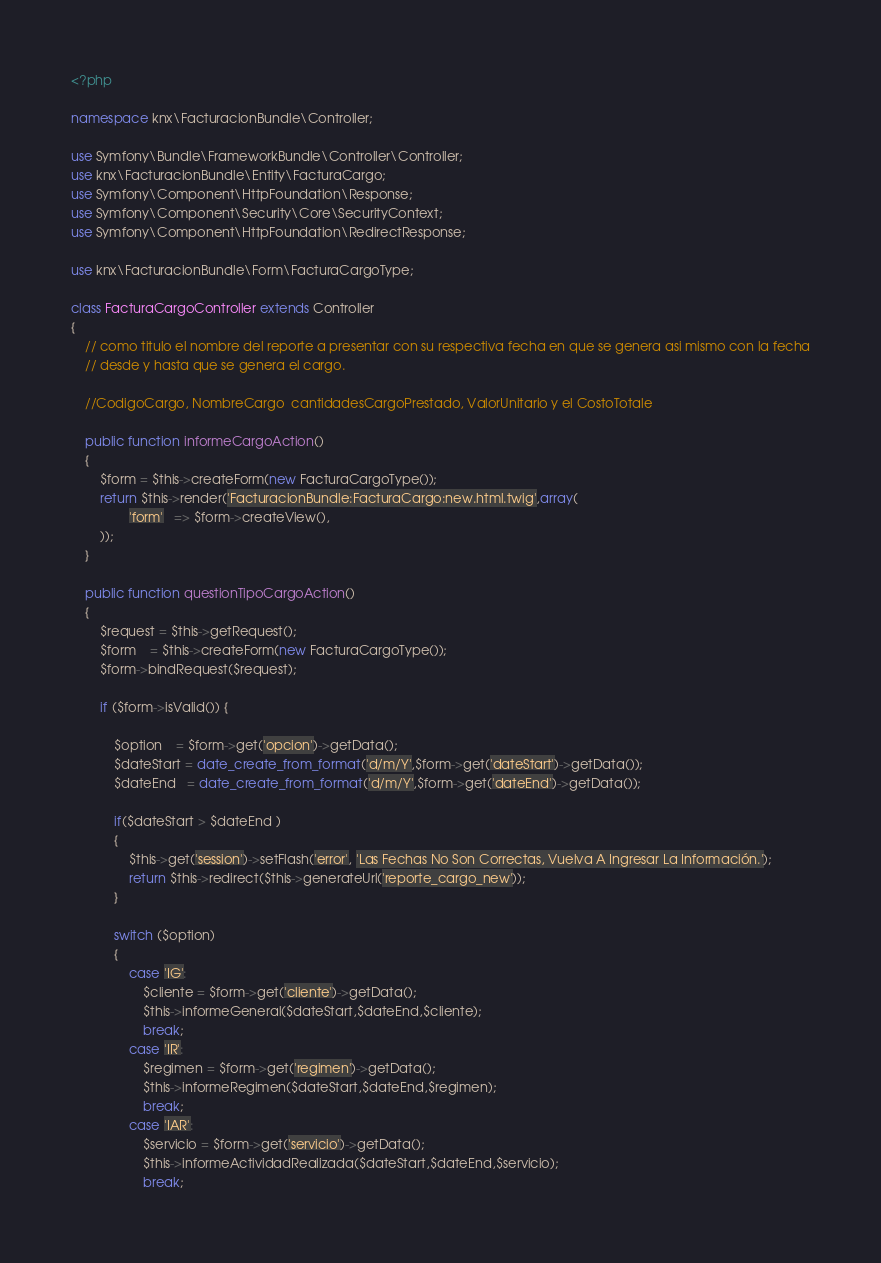Convert code to text. <code><loc_0><loc_0><loc_500><loc_500><_PHP_><?php

namespace knx\FacturacionBundle\Controller;

use Symfony\Bundle\FrameworkBundle\Controller\Controller;
use knx\FacturacionBundle\Entity\FacturaCargo;
use Symfony\Component\HttpFoundation\Response;
use Symfony\Component\Security\Core\SecurityContext;
use Symfony\Component\HttpFoundation\RedirectResponse;

use knx\FacturacionBundle\Form\FacturaCargoType;

class FacturaCargoController extends Controller
{
	// como titulo el nombre del reporte a presentar con su respectiva fecha en que se genera asi mismo con la fecha
	// desde y hasta que se genera el cargo.

	//CodigoCargo, NombreCargo  cantidadesCargoPrestado, ValorUnitario y el CostoTotale

	public function informeCargoAction()
	{
		$form = $this->createForm(new FacturaCargoType());
		return $this->render('FacturacionBundle:FacturaCargo:new.html.twig',array(
    			'form'   => $form->createView(),
    	));
	}

	public function questionTipoCargoAction()
	{
		$request = $this->getRequest();
		$form    = $this->createForm(new FacturaCargoType());
		$form->bindRequest($request);

		if ($form->isValid()) {

			$option    = $form->get('opcion')->getData();
			$dateStart = date_create_from_format('d/m/Y',$form->get('dateStart')->getData());
			$dateEnd   = date_create_from_format('d/m/Y',$form->get('dateEnd')->getData());

			if($dateStart > $dateEnd )
			{
				$this->get('session')->setFlash('error', 'Las Fechas No Son Correctas, Vuelva A Ingresar La Información.');
				return $this->redirect($this->generateUrl('reporte_cargo_new'));
			}

			switch ($option)
			{
				case 'IG':					
					$cliente = $form->get('cliente')->getData();					
					$this->informeGeneral($dateStart,$dateEnd,$cliente);
					break;
				case 'IR':
					$regimen = $form->get('regimen')->getData();					
					$this->informeRegimen($dateStart,$dateEnd,$regimen);
					break;
				case 'IAR':
					$servicio = $form->get('servicio')->getData();
					$this->informeActividadRealizada($dateStart,$dateEnd,$servicio);
					break;</code> 